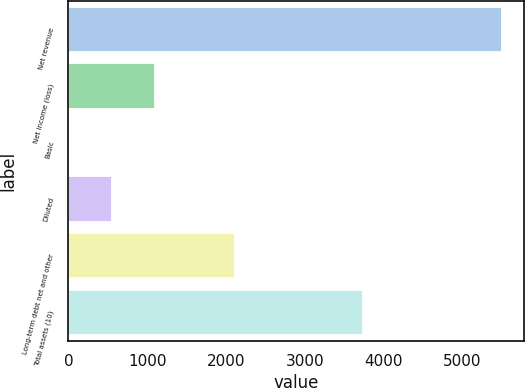Convert chart. <chart><loc_0><loc_0><loc_500><loc_500><bar_chart><fcel>Net revenue<fcel>Net income (loss)<fcel>Basic<fcel>Diluted<fcel>Long-term debt net and other<fcel>Total assets (10)<nl><fcel>5506<fcel>1101.63<fcel>0.53<fcel>551.08<fcel>2110<fcel>3737<nl></chart> 